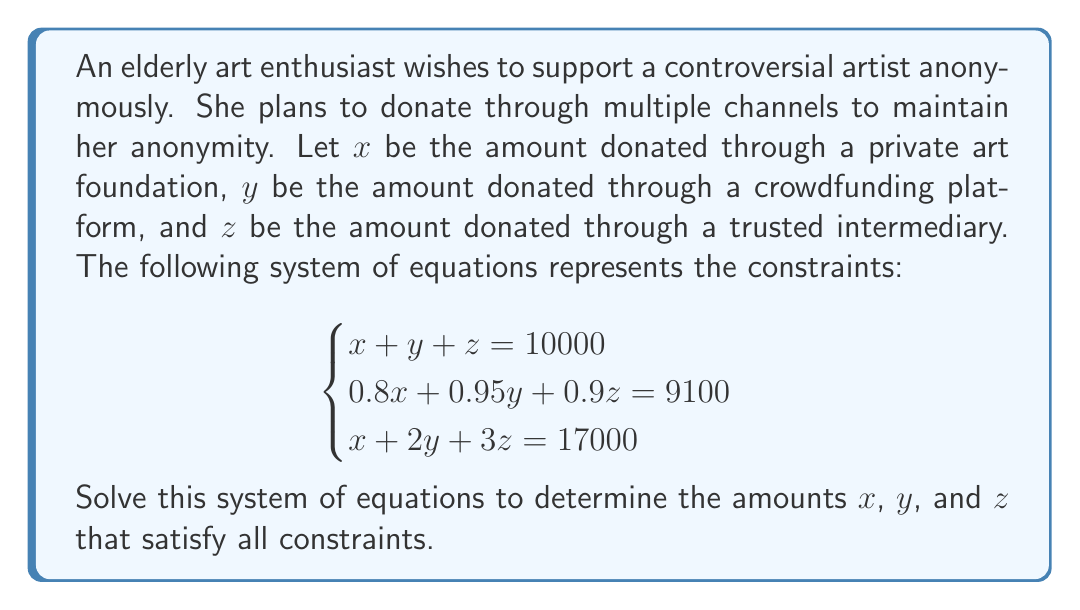Help me with this question. To solve this system of equations, we'll use the elimination method:

1) First, let's multiply the first equation by 0.8 to align the coefficients of $x$:
   $$0.8x + 0.8y + 0.8z = 8000 \quad \text{(Equation 4)}$$

2) Now subtract Equation 4 from the second equation:
   $$(0.95 - 0.8)y + (0.9 - 0.8)z = 9100 - 8000$$
   $$0.15y + 0.1z = 1100 \quad \text{(Equation 5)}$$

3) Multiply Equation 5 by 10 to eliminate decimals:
   $$1.5y + z = 11000 \quad \text{(Equation 6)}$$

4) Now, subtract the first equation from the third equation:
   $$y + 2z = 7000 \quad \text{(Equation 7)}$$

5) Multiply Equation 7 by 1.5:
   $$1.5y + 3z = 10500 \quad \text{(Equation 8)}$$

6) Subtract Equation 6 from Equation 8:
   $$2z = -500$$
   $$z = -250$$

7) Substitute $z = -250$ into Equation 7:
   $$y + 2(-250) = 7000$$
   $$y = 7500$$

8) Finally, substitute $y = 7500$ and $z = -250$ into the first equation:
   $$x + 7500 + (-250) = 10000$$
   $$x = 2750$$

Therefore, the solution to the system of equations is:
$x = 2750$, $y = 7500$, and $z = -250$.

However, since $z$ represents a donation amount, a negative value is not practical in this context. This suggests that the given constraints cannot be satisfied simultaneously with non-negative donations through all three channels.
Answer: The system has no practical solution as it yields negative values. The mathematical solution is $x = 2750$, $y = 7500$, $z = -250$, but this is not feasible for real-world donations. 